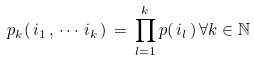<formula> <loc_0><loc_0><loc_500><loc_500>p _ { k } ( \, i _ { 1 } \, , \, \cdots \, i _ { k } \, ) \, = \, \prod _ { l = 1 } ^ { k } p ( \, i _ { l } \, ) \, \forall k \in { \mathbb { N } }</formula> 